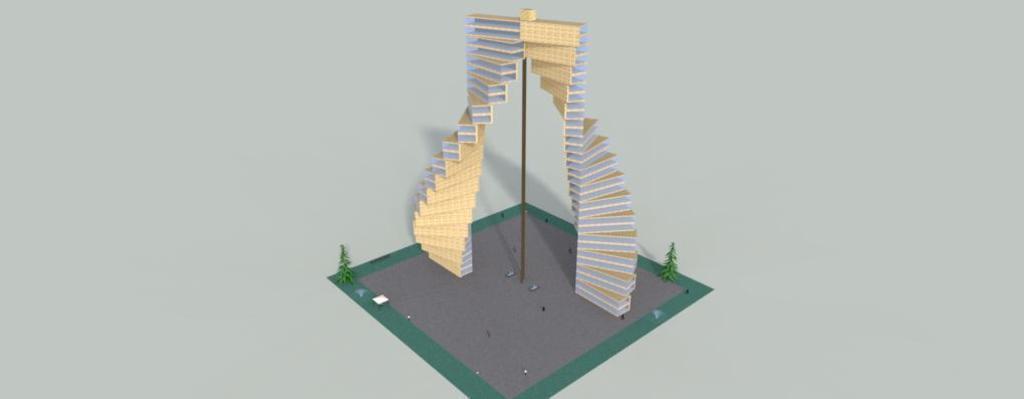Describe this image in one or two sentences. The image looks like an edited picture. In the center of the picture we can see a geo scraper. 